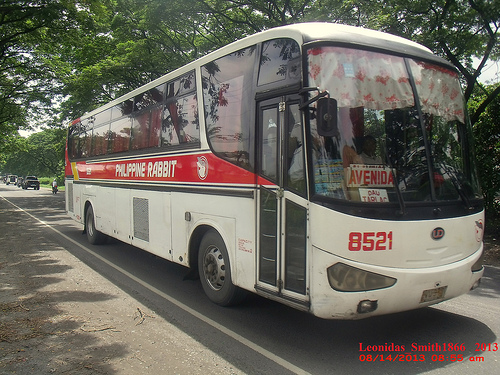<image>
Is the tire next to the headlight? No. The tire is not positioned next to the headlight. They are located in different areas of the scene. Where is the bus in relation to the road? Is it above the road? No. The bus is not positioned above the road. The vertical arrangement shows a different relationship. 